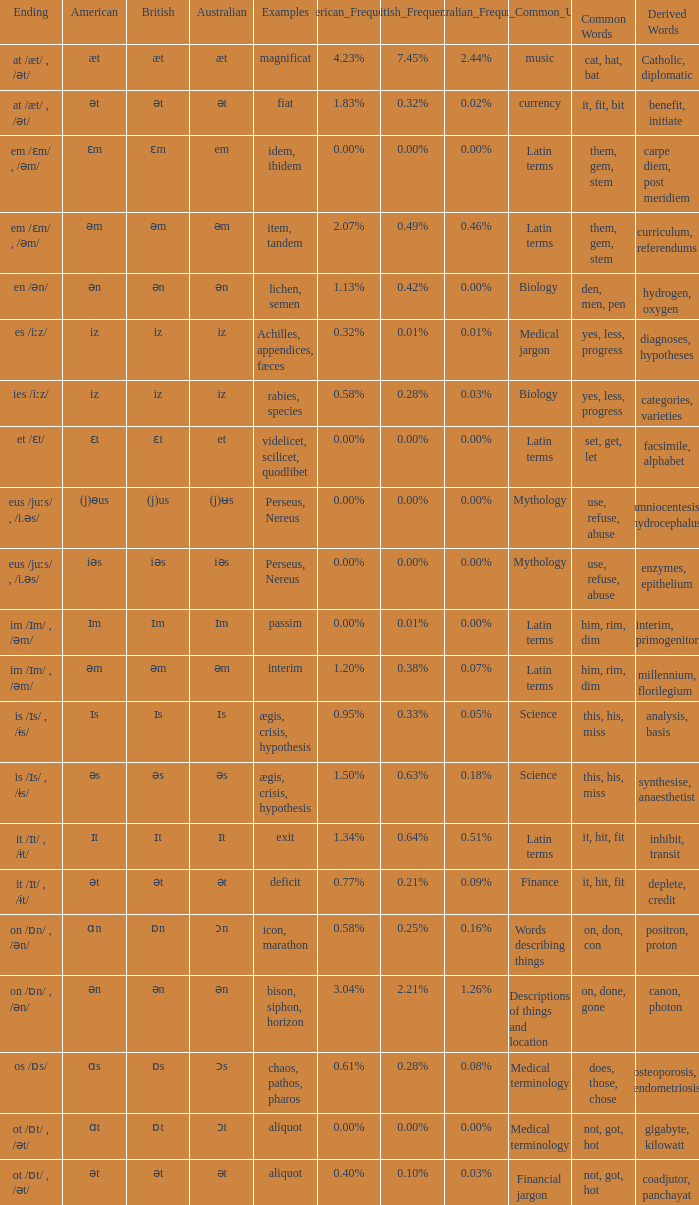Which Australian has British of ɒs? Ɔs. 